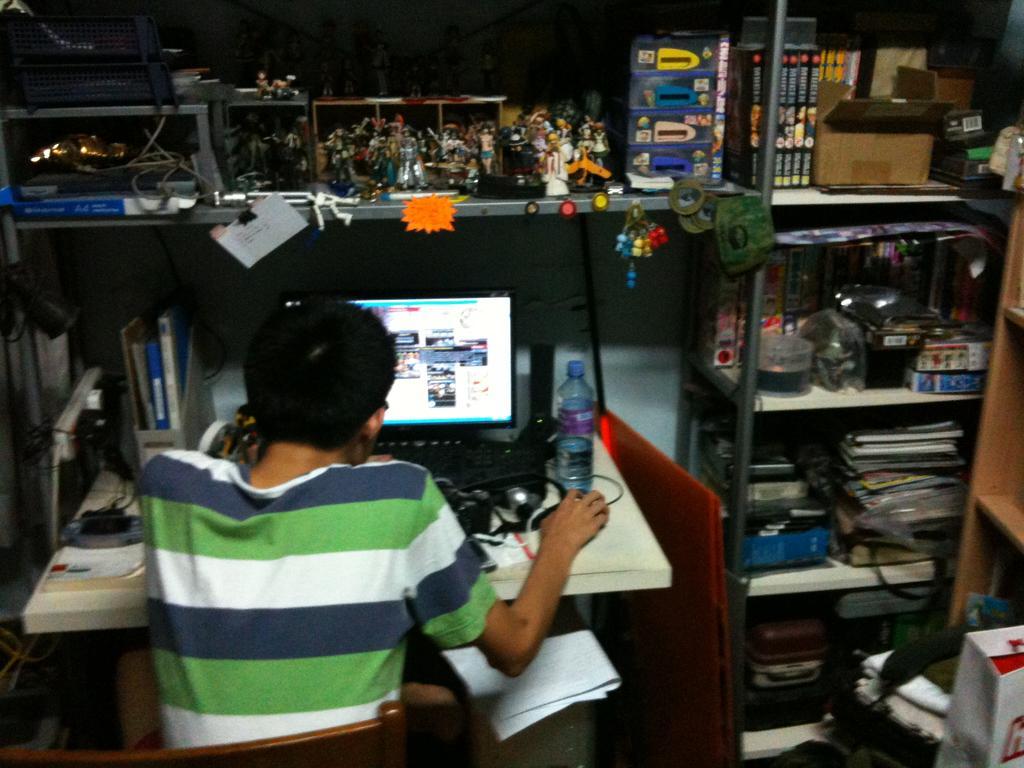Can you describe this image briefly? This is an inside view. Here I can see a person sitting on a chair facing towards the back side. In front of this person there is a table on which a monitor, bottle, cables, books and many other objects are placed. This person is looking into the monitor. In the background there are many books, bottles, boxes, toys and other objects placed in the racks. In the bottom right-hand corner a bag and some other objects are placed on the floor. The background is dark. 